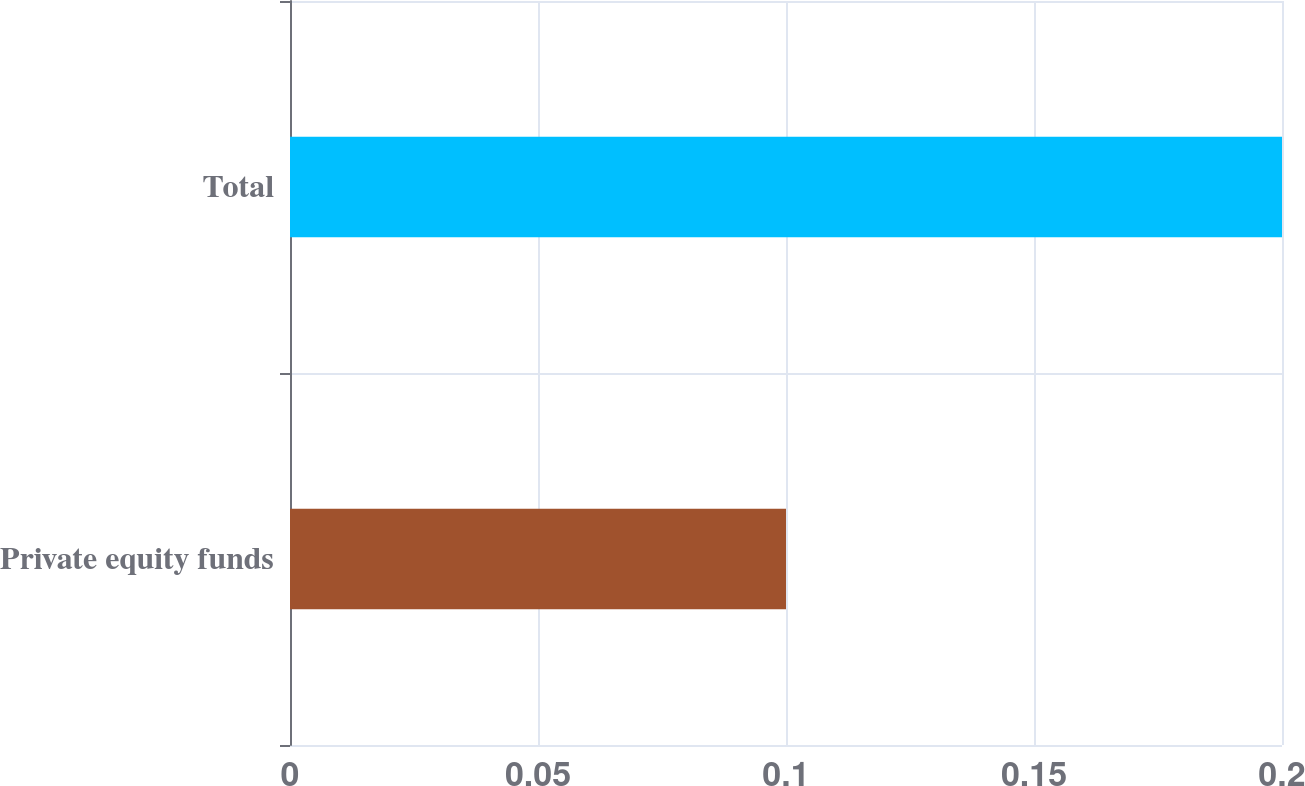Convert chart. <chart><loc_0><loc_0><loc_500><loc_500><bar_chart><fcel>Private equity funds<fcel>Total<nl><fcel>0.1<fcel>0.2<nl></chart> 